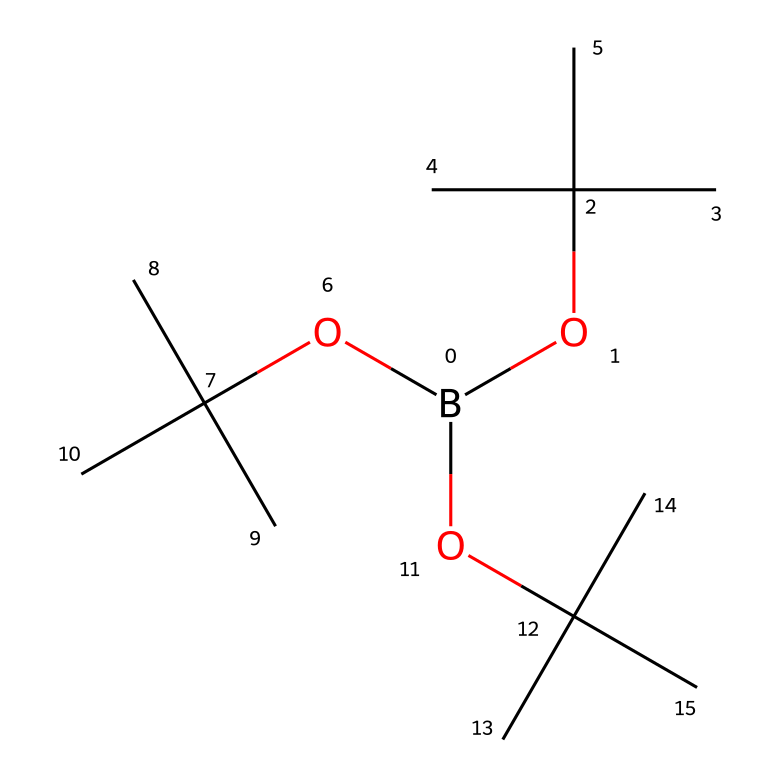What type of functional groups are present in this chemical? This chemical structure has three different groups, all of which are tert-butoxy groups, which are represented by the part containig "OC(C)(C)C". Each group features a central carbon atom bonded to three methyl groups and an oxygen atom linking it to boron.
Answer: tert-butoxy How many boron atoms are present in the structure? By examining the SMILES representation, we find that there is one 'B' at the beginning, indicating a single boron atom in the molecule.
Answer: one What is the total number of carbon atoms in this molecule? Each tert-butoxy has four carbon atoms (one central carbon and three from the methyl groups). Since there are three tert-butoxy groups, we multiply 4 by 3, resulting in 12 carbon atoms overall.
Answer: twelve Can this chemical be classified as a polymer? The structure indicates multiple connections to a central boron atom with branches indicating that it can form complex structures or networks typically associated with polymers. However, it is not classified as a traditional polymer.
Answer: no What geometric configuration does the boron atom likely exhibit? Boron typically adopts a trigonal planar geometry due to its three substituents (the three tert-butoxy groups) arranged around it.
Answer: trigonal planar Is this chemical expected to be hydrophobic or hydrophilic? The presence of multiple carbon groups typically suggests a hydrophobic nature. The bulky tert-butoxy groups are nonpolar and less likely to interact with water.
Answer: hydrophobic 